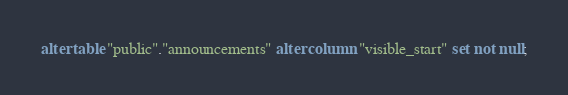Convert code to text. <code><loc_0><loc_0><loc_500><loc_500><_SQL_>alter table "public"."announcements" alter column "visible_start" set not null;
</code> 